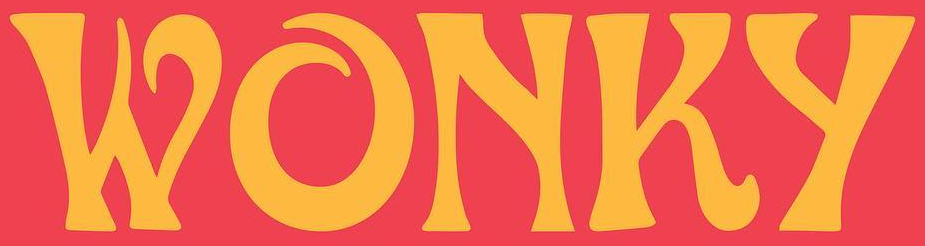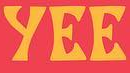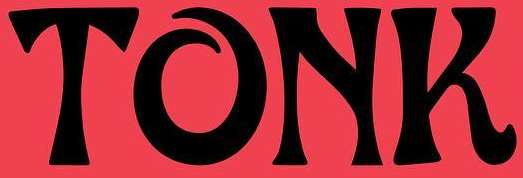What text appears in these images from left to right, separated by a semicolon? WONKy; yEE; TONK 